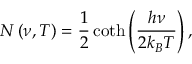<formula> <loc_0><loc_0><loc_500><loc_500>N \left ( \nu , T \right ) = \frac { 1 } { 2 } \coth \left ( \frac { h \nu } { 2 k _ { B } T } \right ) ,</formula> 